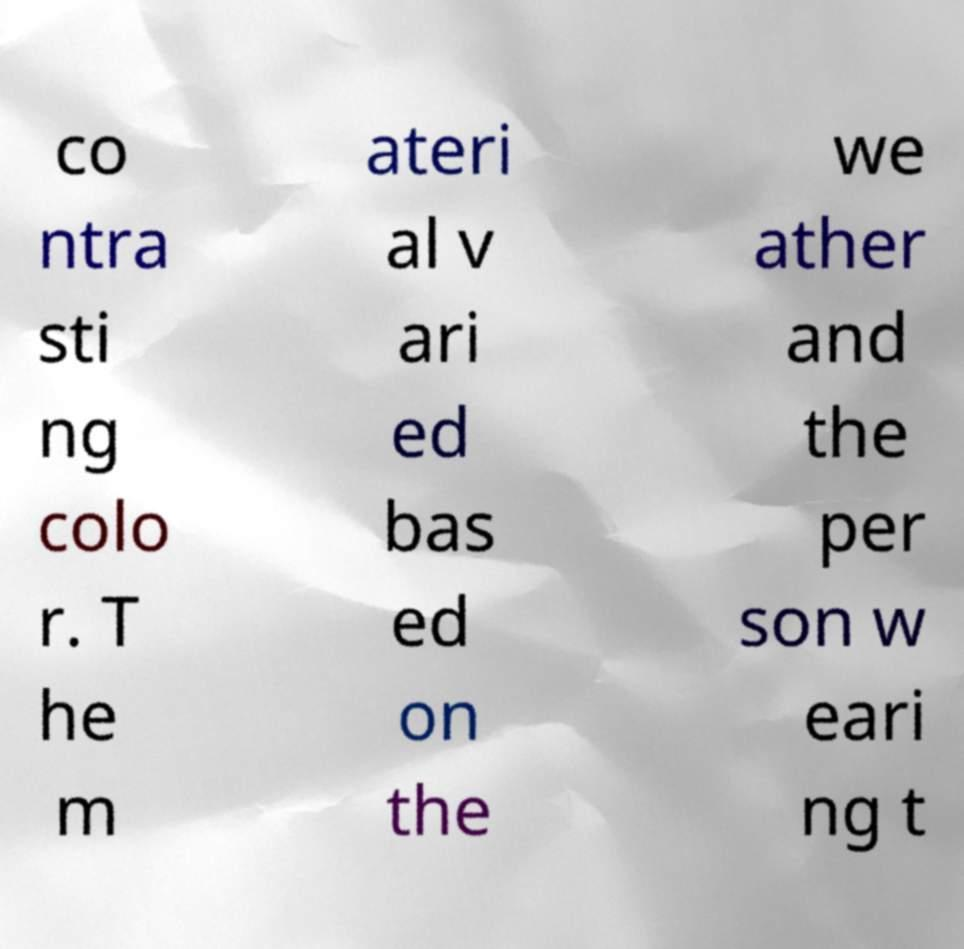Could you assist in decoding the text presented in this image and type it out clearly? co ntra sti ng colo r. T he m ateri al v ari ed bas ed on the we ather and the per son w eari ng t 